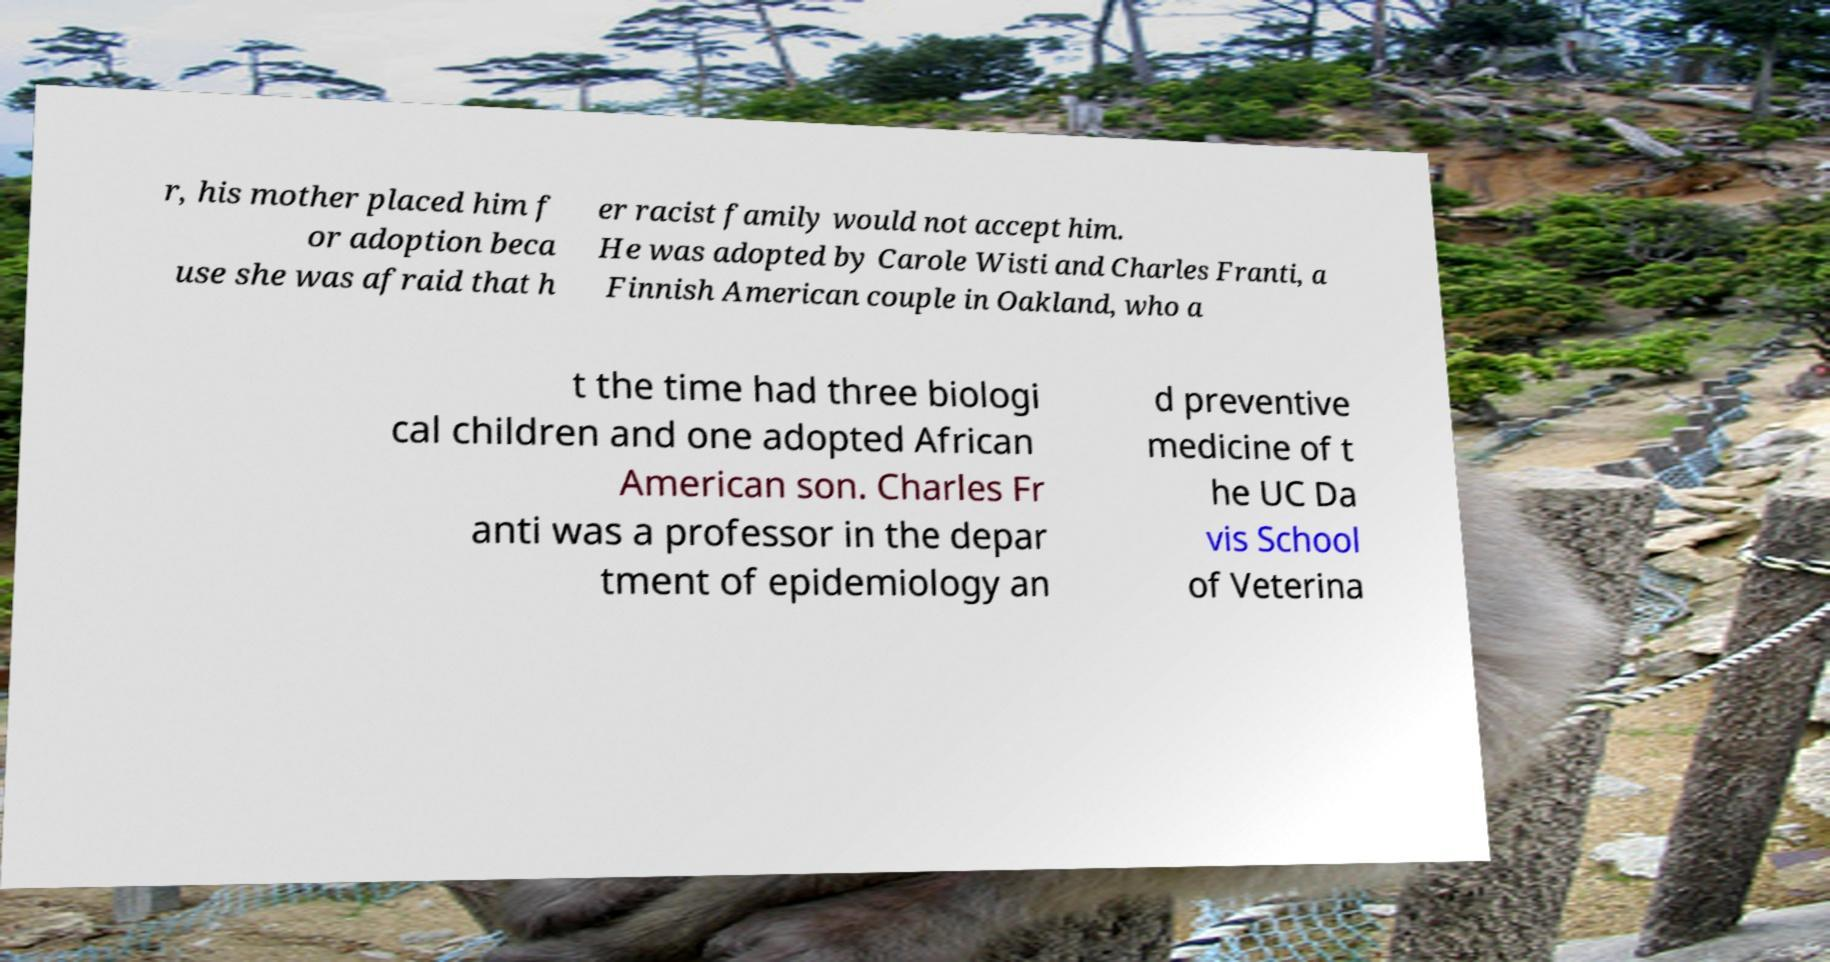I need the written content from this picture converted into text. Can you do that? r, his mother placed him f or adoption beca use she was afraid that h er racist family would not accept him. He was adopted by Carole Wisti and Charles Franti, a Finnish American couple in Oakland, who a t the time had three biologi cal children and one adopted African American son. Charles Fr anti was a professor in the depar tment of epidemiology an d preventive medicine of t he UC Da vis School of Veterina 